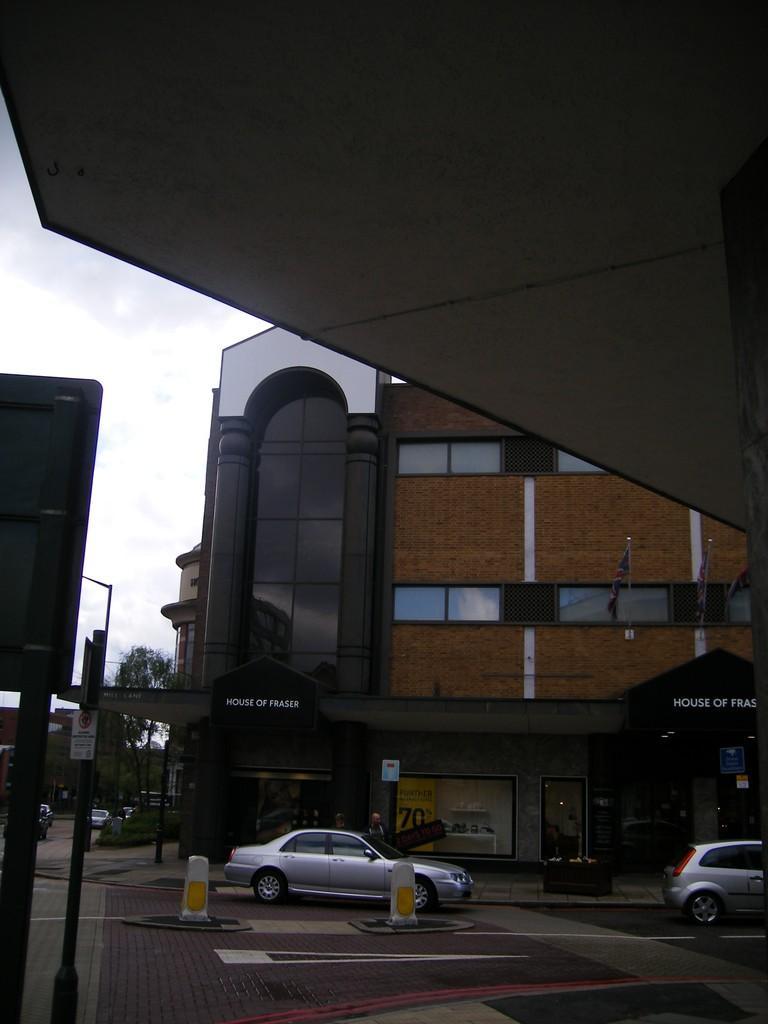Can you describe this image briefly? This picture is clicked outside. In the center we can see the cars, buildings and poles and some other objects are placed on the ground. In the background we can see the sky, tree and buildings. 